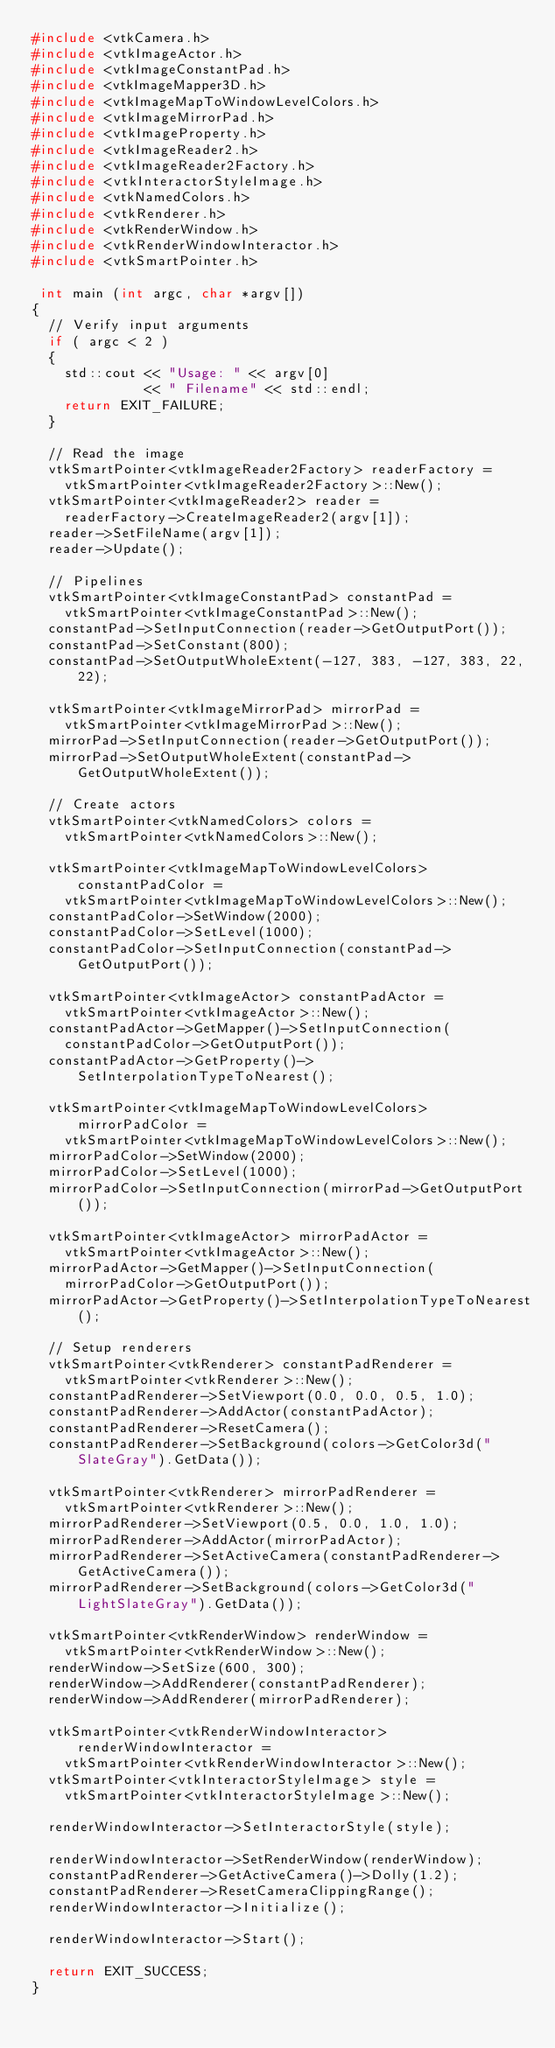<code> <loc_0><loc_0><loc_500><loc_500><_C++_>#include <vtkCamera.h>
#include <vtkImageActor.h>
#include <vtkImageConstantPad.h>
#include <vtkImageMapper3D.h>
#include <vtkImageMapToWindowLevelColors.h>
#include <vtkImageMirrorPad.h>
#include <vtkImageProperty.h>
#include <vtkImageReader2.h>
#include <vtkImageReader2Factory.h>
#include <vtkInteractorStyleImage.h>
#include <vtkNamedColors.h>
#include <vtkRenderer.h>
#include <vtkRenderWindow.h>
#include <vtkRenderWindowInteractor.h>
#include <vtkSmartPointer.h>

 int main (int argc, char *argv[])
{
  // Verify input arguments
  if ( argc < 2 )
  {
    std::cout << "Usage: " << argv[0]
              << " Filename" << std::endl;
    return EXIT_FAILURE;
  }

  // Read the image
  vtkSmartPointer<vtkImageReader2Factory> readerFactory =
    vtkSmartPointer<vtkImageReader2Factory>::New();
  vtkSmartPointer<vtkImageReader2> reader =
    readerFactory->CreateImageReader2(argv[1]);
  reader->SetFileName(argv[1]);
  reader->Update();

  // Pipelines
  vtkSmartPointer<vtkImageConstantPad> constantPad =
    vtkSmartPointer<vtkImageConstantPad>::New();
  constantPad->SetInputConnection(reader->GetOutputPort());
  constantPad->SetConstant(800);
  constantPad->SetOutputWholeExtent(-127, 383, -127, 383, 22, 22);

  vtkSmartPointer<vtkImageMirrorPad> mirrorPad =
    vtkSmartPointer<vtkImageMirrorPad>::New();
  mirrorPad->SetInputConnection(reader->GetOutputPort());
  mirrorPad->SetOutputWholeExtent(constantPad->GetOutputWholeExtent());

  // Create actors
  vtkSmartPointer<vtkNamedColors> colors =
    vtkSmartPointer<vtkNamedColors>::New();

  vtkSmartPointer<vtkImageMapToWindowLevelColors> constantPadColor =
    vtkSmartPointer<vtkImageMapToWindowLevelColors>::New();
  constantPadColor->SetWindow(2000);
  constantPadColor->SetLevel(1000);
  constantPadColor->SetInputConnection(constantPad->GetOutputPort());

  vtkSmartPointer<vtkImageActor> constantPadActor =
    vtkSmartPointer<vtkImageActor>::New();
  constantPadActor->GetMapper()->SetInputConnection(
    constantPadColor->GetOutputPort());
  constantPadActor->GetProperty()->SetInterpolationTypeToNearest();

  vtkSmartPointer<vtkImageMapToWindowLevelColors> mirrorPadColor =
    vtkSmartPointer<vtkImageMapToWindowLevelColors>::New();
  mirrorPadColor->SetWindow(2000);
  mirrorPadColor->SetLevel(1000);
  mirrorPadColor->SetInputConnection(mirrorPad->GetOutputPort());

  vtkSmartPointer<vtkImageActor> mirrorPadActor =
    vtkSmartPointer<vtkImageActor>::New();
  mirrorPadActor->GetMapper()->SetInputConnection(
    mirrorPadColor->GetOutputPort());
  mirrorPadActor->GetProperty()->SetInterpolationTypeToNearest();

  // Setup renderers
  vtkSmartPointer<vtkRenderer> constantPadRenderer =
    vtkSmartPointer<vtkRenderer>::New();
  constantPadRenderer->SetViewport(0.0, 0.0, 0.5, 1.0);
  constantPadRenderer->AddActor(constantPadActor);
  constantPadRenderer->ResetCamera();
  constantPadRenderer->SetBackground(colors->GetColor3d("SlateGray").GetData());

  vtkSmartPointer<vtkRenderer> mirrorPadRenderer =
    vtkSmartPointer<vtkRenderer>::New();
  mirrorPadRenderer->SetViewport(0.5, 0.0, 1.0, 1.0);
  mirrorPadRenderer->AddActor(mirrorPadActor);
  mirrorPadRenderer->SetActiveCamera(constantPadRenderer->GetActiveCamera());
  mirrorPadRenderer->SetBackground(colors->GetColor3d("LightSlateGray").GetData());

  vtkSmartPointer<vtkRenderWindow> renderWindow =
    vtkSmartPointer<vtkRenderWindow>::New();
  renderWindow->SetSize(600, 300);
  renderWindow->AddRenderer(constantPadRenderer);
  renderWindow->AddRenderer(mirrorPadRenderer);

  vtkSmartPointer<vtkRenderWindowInteractor> renderWindowInteractor =
    vtkSmartPointer<vtkRenderWindowInteractor>::New();
  vtkSmartPointer<vtkInteractorStyleImage> style =
    vtkSmartPointer<vtkInteractorStyleImage>::New();

  renderWindowInteractor->SetInteractorStyle(style);

  renderWindowInteractor->SetRenderWindow(renderWindow);
  constantPadRenderer->GetActiveCamera()->Dolly(1.2);
  constantPadRenderer->ResetCameraClippingRange();
  renderWindowInteractor->Initialize();

  renderWindowInteractor->Start();

  return EXIT_SUCCESS;
}
</code> 